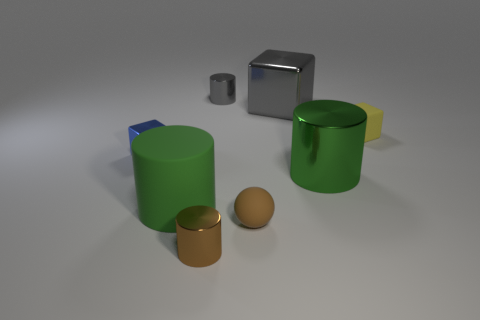Subtract all green cylinders. How many were subtracted if there are1green cylinders left? 1 Subtract all blue balls. How many green cylinders are left? 2 Subtract 2 cylinders. How many cylinders are left? 2 Subtract all large cubes. How many cubes are left? 2 Subtract all gray cylinders. How many cylinders are left? 3 Add 1 green rubber cylinders. How many objects exist? 9 Subtract 1 blue cubes. How many objects are left? 7 Subtract all cubes. How many objects are left? 5 Subtract all yellow cylinders. Subtract all gray spheres. How many cylinders are left? 4 Subtract all big green metal cubes. Subtract all cubes. How many objects are left? 5 